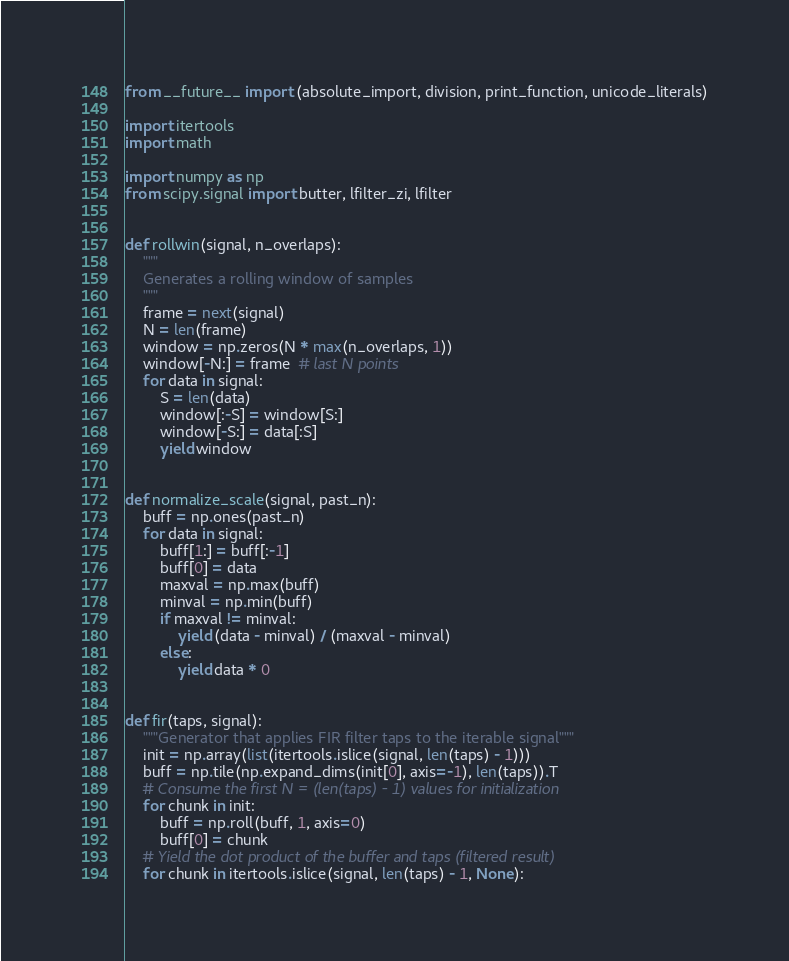<code> <loc_0><loc_0><loc_500><loc_500><_Python_>from __future__ import (absolute_import, division, print_function, unicode_literals)

import itertools
import math

import numpy as np
from scipy.signal import butter, lfilter_zi, lfilter


def rollwin(signal, n_overlaps):
    """
    Generates a rolling window of samples
    """
    frame = next(signal)
    N = len(frame)
    window = np.zeros(N * max(n_overlaps, 1))
    window[-N:] = frame  # last N points
    for data in signal:
        S = len(data)
        window[:-S] = window[S:]
        window[-S:] = data[:S]
        yield window


def normalize_scale(signal, past_n):
    buff = np.ones(past_n)
    for data in signal:
        buff[1:] = buff[:-1]
        buff[0] = data
        maxval = np.max(buff)
        minval = np.min(buff)
        if maxval != minval:
            yield (data - minval) / (maxval - minval)
        else:
            yield data * 0


def fir(taps, signal):
    """Generator that applies FIR filter taps to the iterable signal"""
    init = np.array(list(itertools.islice(signal, len(taps) - 1)))
    buff = np.tile(np.expand_dims(init[0], axis=-1), len(taps)).T
    # Consume the first N = (len(taps) - 1) values for initialization
    for chunk in init:
        buff = np.roll(buff, 1, axis=0)
        buff[0] = chunk
    # Yield the dot product of the buffer and taps (filtered result)
    for chunk in itertools.islice(signal, len(taps) - 1, None):</code> 